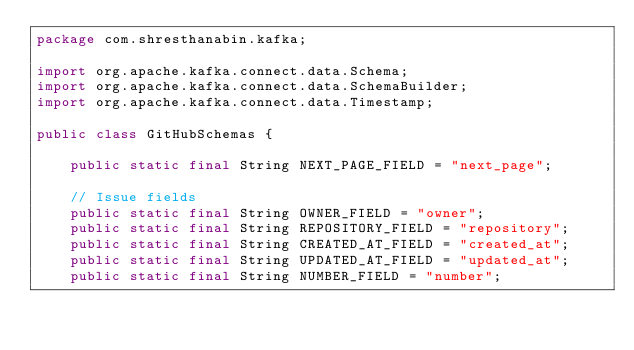<code> <loc_0><loc_0><loc_500><loc_500><_Java_>package com.shresthanabin.kafka;

import org.apache.kafka.connect.data.Schema;
import org.apache.kafka.connect.data.SchemaBuilder;
import org.apache.kafka.connect.data.Timestamp;

public class GitHubSchemas {

    public static final String NEXT_PAGE_FIELD = "next_page";

    // Issue fields
    public static final String OWNER_FIELD = "owner";
    public static final String REPOSITORY_FIELD = "repository";
    public static final String CREATED_AT_FIELD = "created_at";
    public static final String UPDATED_AT_FIELD = "updated_at";
    public static final String NUMBER_FIELD = "number";</code> 